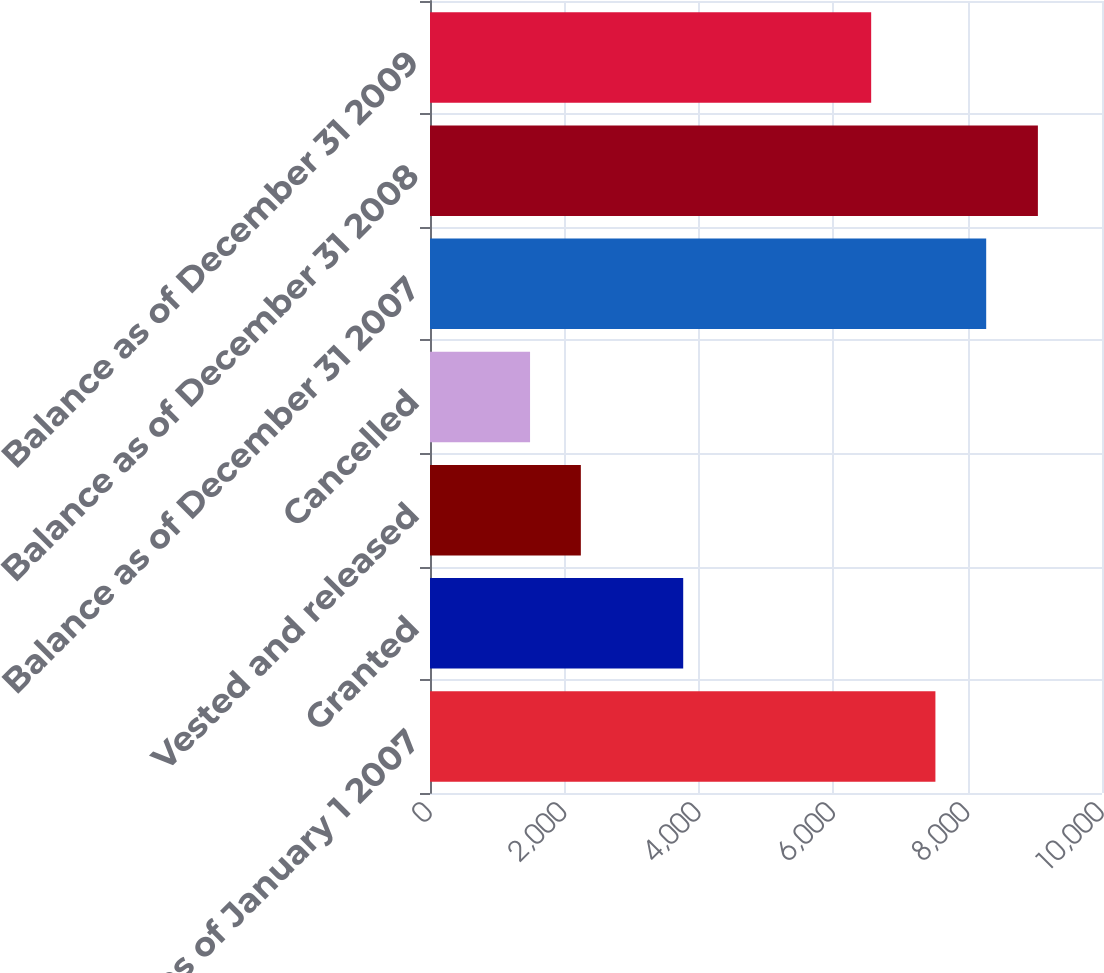Convert chart. <chart><loc_0><loc_0><loc_500><loc_500><bar_chart><fcel>Balance as of January 1 2007<fcel>Granted<fcel>Vested and released<fcel>Cancelled<fcel>Balance as of December 31 2007<fcel>Balance as of December 31 2008<fcel>Balance as of December 31 2009<nl><fcel>7521<fcel>3768<fcel>2244.7<fcel>1489<fcel>8276.7<fcel>9046<fcel>6565<nl></chart> 